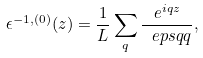Convert formula to latex. <formula><loc_0><loc_0><loc_500><loc_500>\epsilon ^ { - 1 , ( 0 ) } ( z ) = \frac { 1 } { L } \sum _ { q } \frac { e ^ { i q z } } { \ e p s q { q } } ,</formula> 